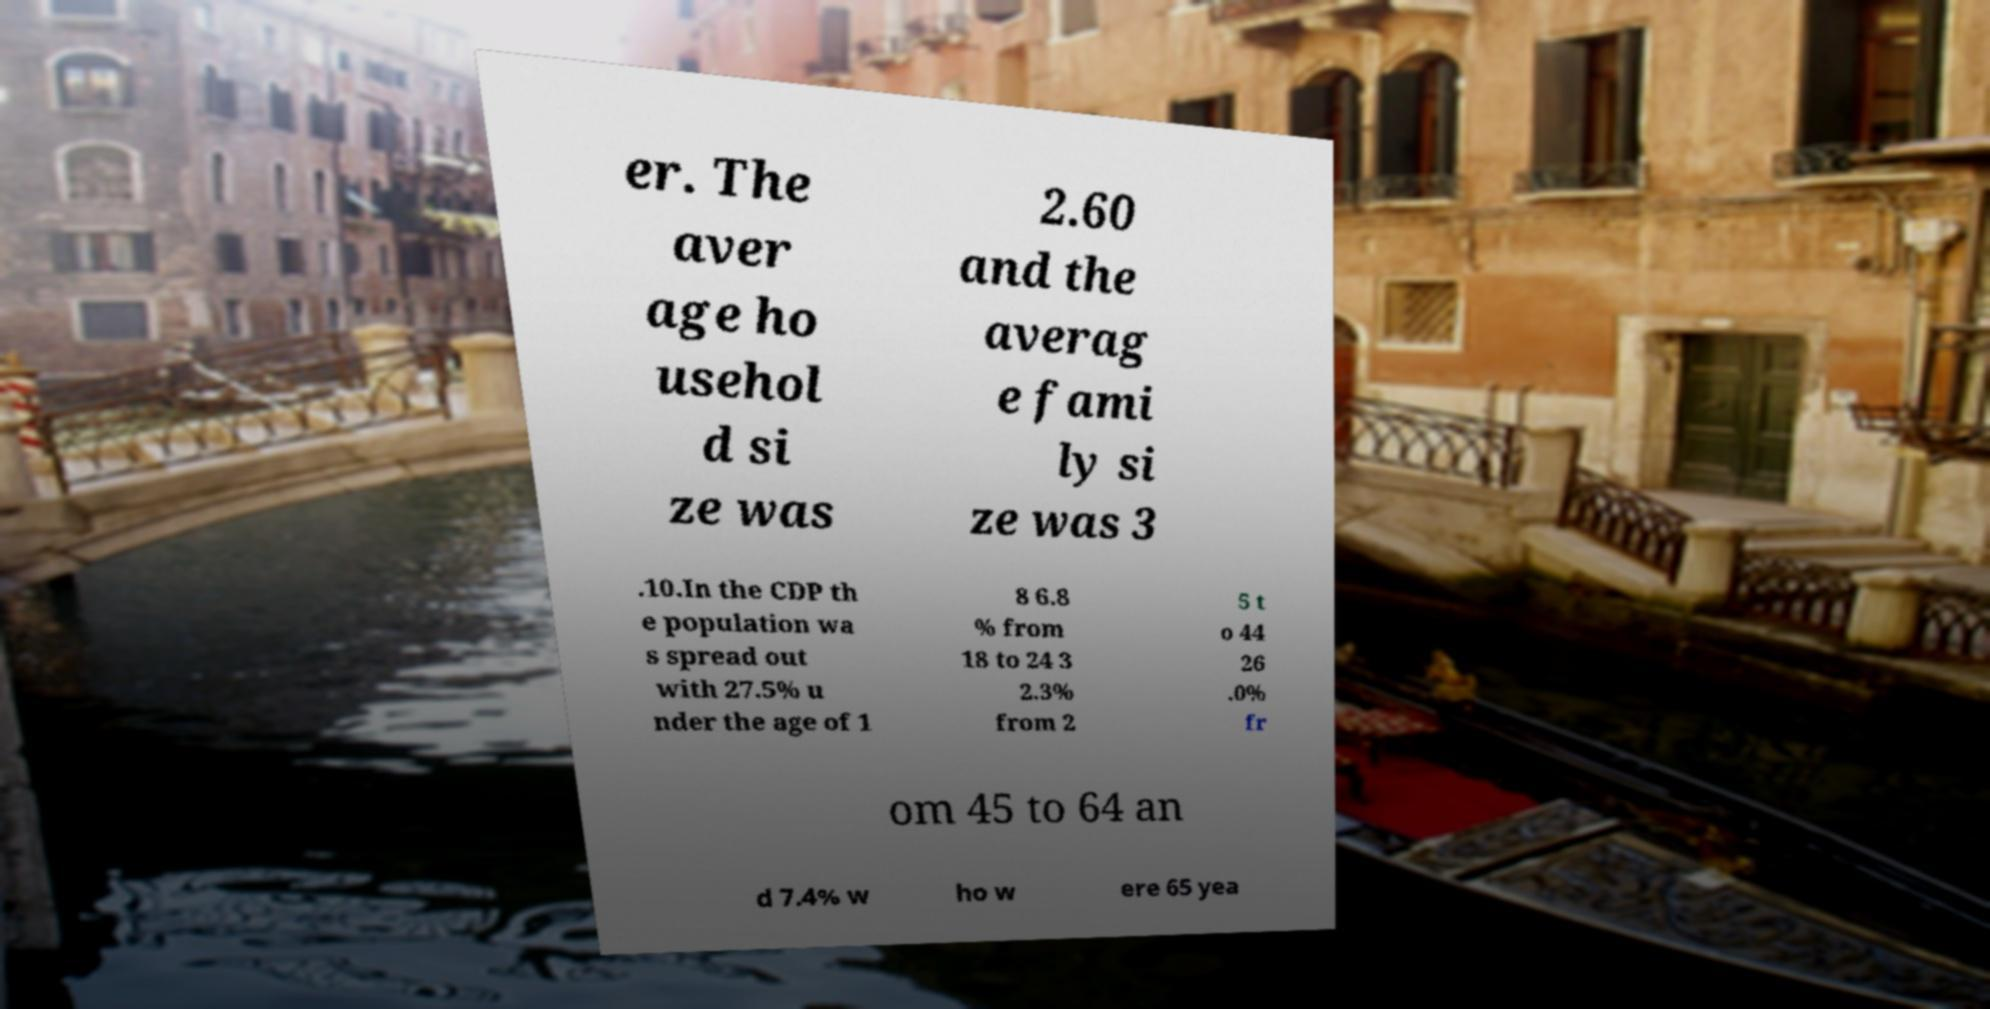I need the written content from this picture converted into text. Can you do that? er. The aver age ho usehol d si ze was 2.60 and the averag e fami ly si ze was 3 .10.In the CDP th e population wa s spread out with 27.5% u nder the age of 1 8 6.8 % from 18 to 24 3 2.3% from 2 5 t o 44 26 .0% fr om 45 to 64 an d 7.4% w ho w ere 65 yea 